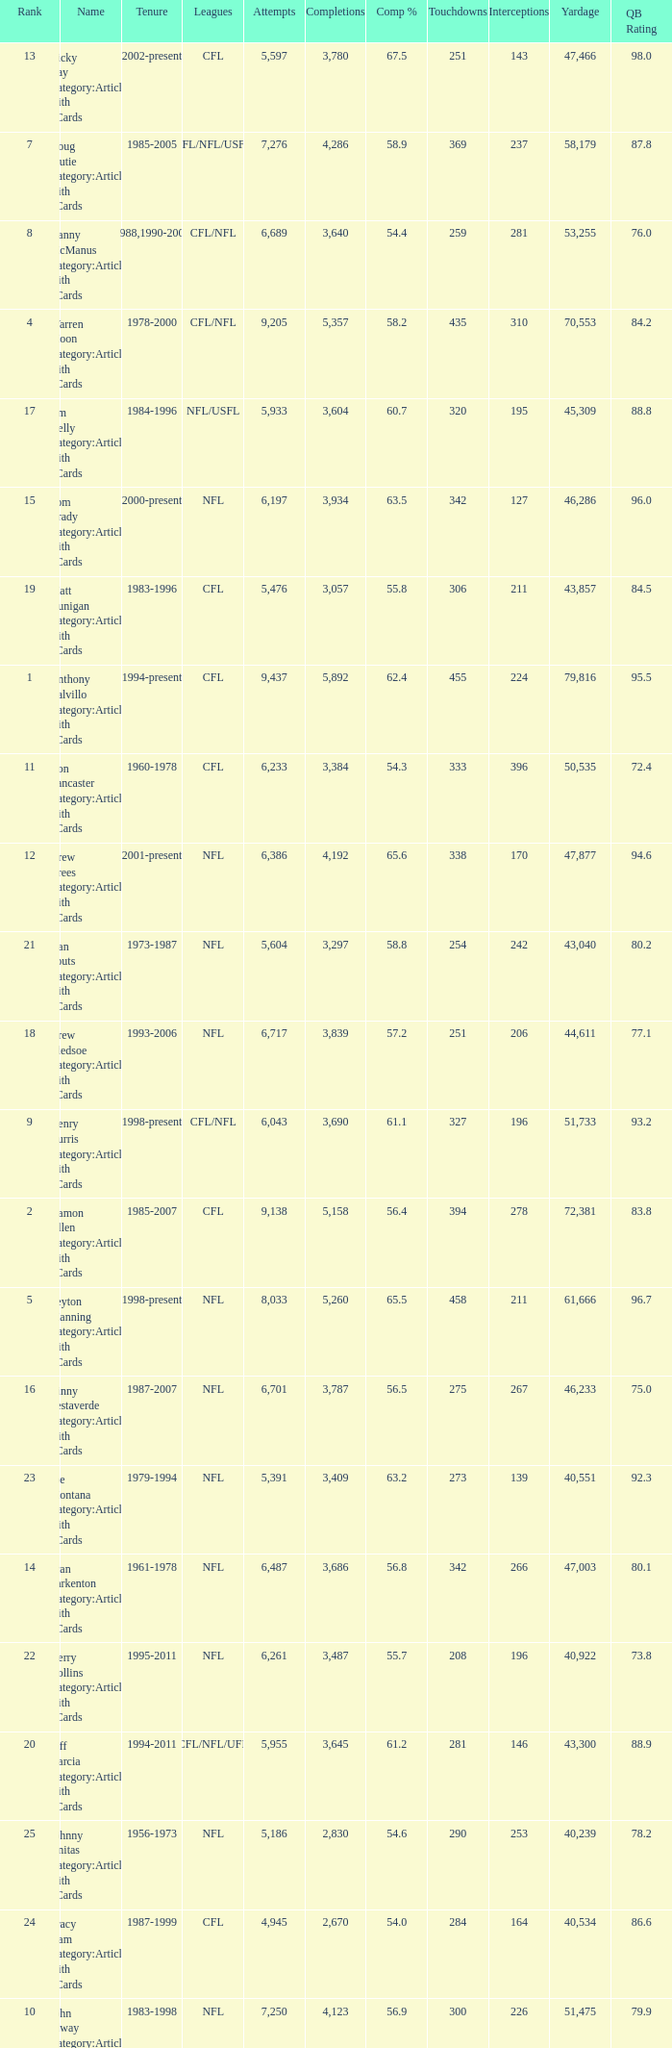What is the rank when there are more than 4,123 completion and the comp percentage is more than 65.6? None. 